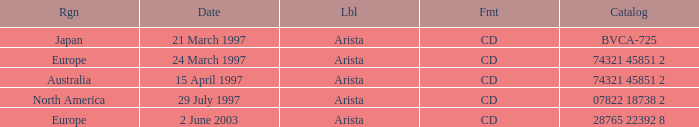What Format has the Region of Europe and a Catalog of 74321 45851 2? CD. 